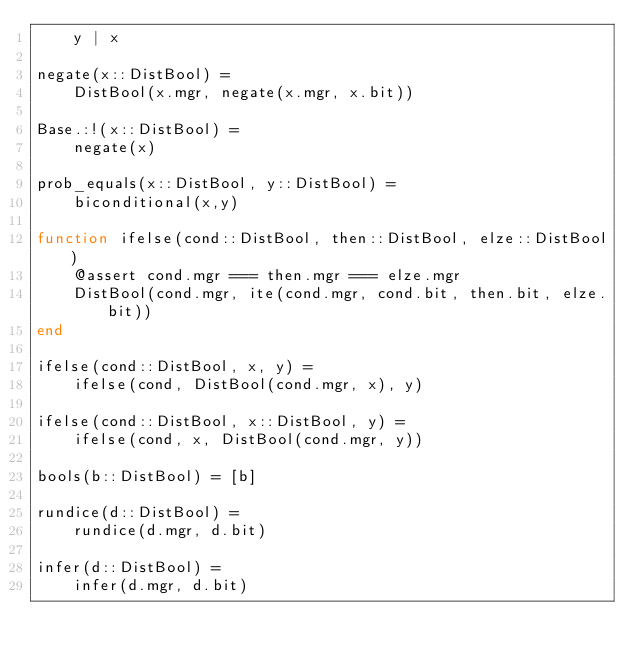<code> <loc_0><loc_0><loc_500><loc_500><_Julia_>    y | x

negate(x::DistBool) =
    DistBool(x.mgr, negate(x.mgr, x.bit))
    
Base.:!(x::DistBool) = 
    negate(x)

prob_equals(x::DistBool, y::DistBool) =
    biconditional(x,y)

function ifelse(cond::DistBool, then::DistBool, elze::DistBool)
    @assert cond.mgr === then.mgr === elze.mgr
    DistBool(cond.mgr, ite(cond.mgr, cond.bit, then.bit, elze.bit))
end

ifelse(cond::DistBool, x, y) = 
    ifelse(cond, DistBool(cond.mgr, x), y)

ifelse(cond::DistBool, x::DistBool, y) = 
    ifelse(cond, x, DistBool(cond.mgr, y))

bools(b::DistBool) = [b]

rundice(d::DistBool) =
    rundice(d.mgr, d.bit) 

infer(d::DistBool) =
    infer(d.mgr, d.bit)</code> 